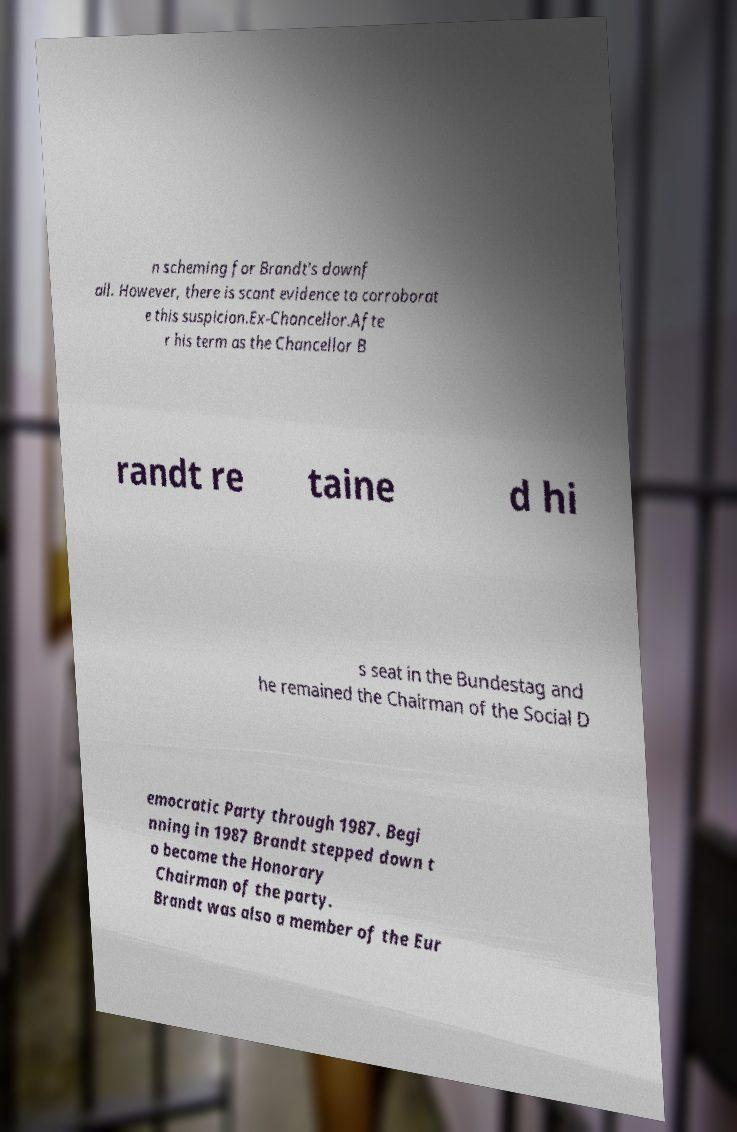Can you accurately transcribe the text from the provided image for me? n scheming for Brandt's downf all. However, there is scant evidence to corroborat e this suspicion.Ex-Chancellor.Afte r his term as the Chancellor B randt re taine d hi s seat in the Bundestag and he remained the Chairman of the Social D emocratic Party through 1987. Begi nning in 1987 Brandt stepped down t o become the Honorary Chairman of the party. Brandt was also a member of the Eur 